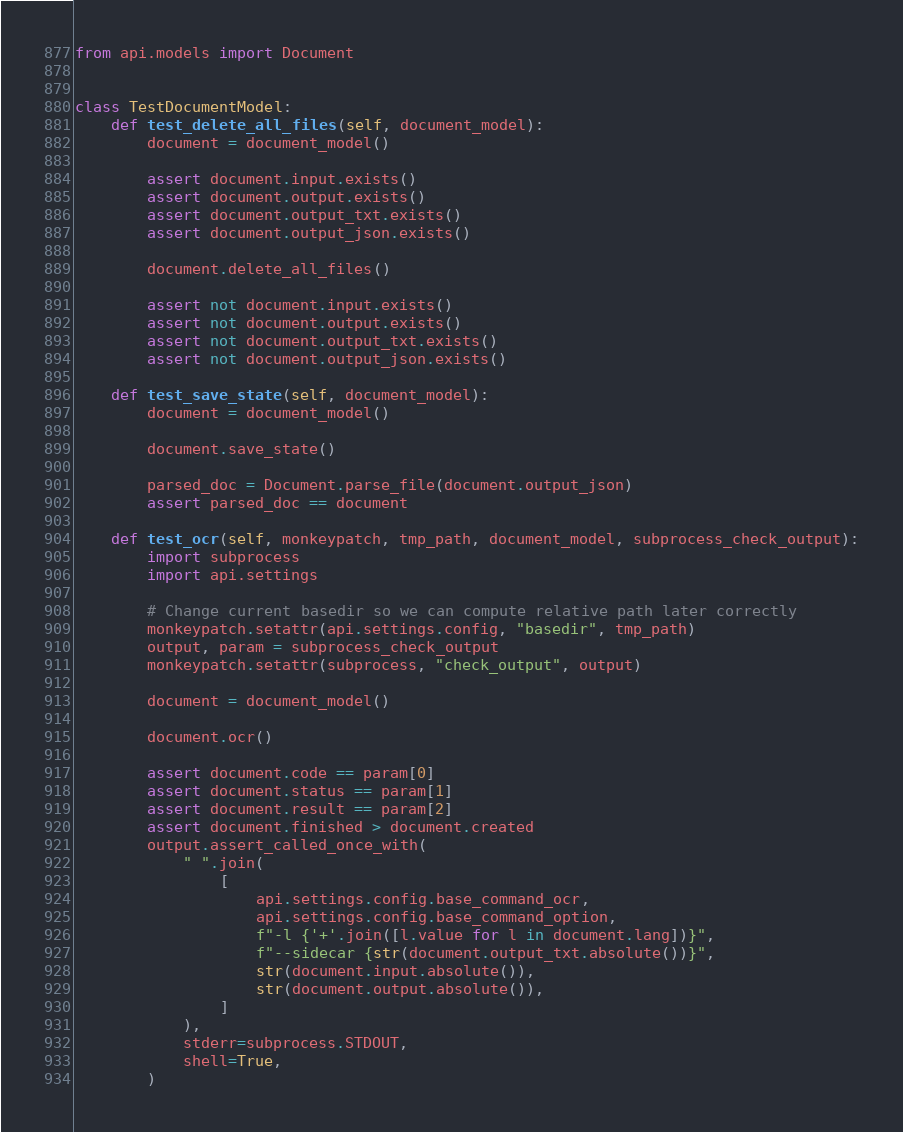<code> <loc_0><loc_0><loc_500><loc_500><_Python_>from api.models import Document


class TestDocumentModel:
    def test_delete_all_files(self, document_model):
        document = document_model()

        assert document.input.exists()
        assert document.output.exists()
        assert document.output_txt.exists()
        assert document.output_json.exists()

        document.delete_all_files()

        assert not document.input.exists()
        assert not document.output.exists()
        assert not document.output_txt.exists()
        assert not document.output_json.exists()

    def test_save_state(self, document_model):
        document = document_model()

        document.save_state()

        parsed_doc = Document.parse_file(document.output_json)
        assert parsed_doc == document

    def test_ocr(self, monkeypatch, tmp_path, document_model, subprocess_check_output):
        import subprocess
        import api.settings

        # Change current basedir so we can compute relative path later correctly
        monkeypatch.setattr(api.settings.config, "basedir", tmp_path)
        output, param = subprocess_check_output
        monkeypatch.setattr(subprocess, "check_output", output)

        document = document_model()

        document.ocr()

        assert document.code == param[0]
        assert document.status == param[1]
        assert document.result == param[2]
        assert document.finished > document.created
        output.assert_called_once_with(
            " ".join(
                [
                    api.settings.config.base_command_ocr,
                    api.settings.config.base_command_option,
                    f"-l {'+'.join([l.value for l in document.lang])}",
                    f"--sidecar {str(document.output_txt.absolute())}",
                    str(document.input.absolute()),
                    str(document.output.absolute()),
                ]
            ),
            stderr=subprocess.STDOUT,
            shell=True,
        )
</code> 